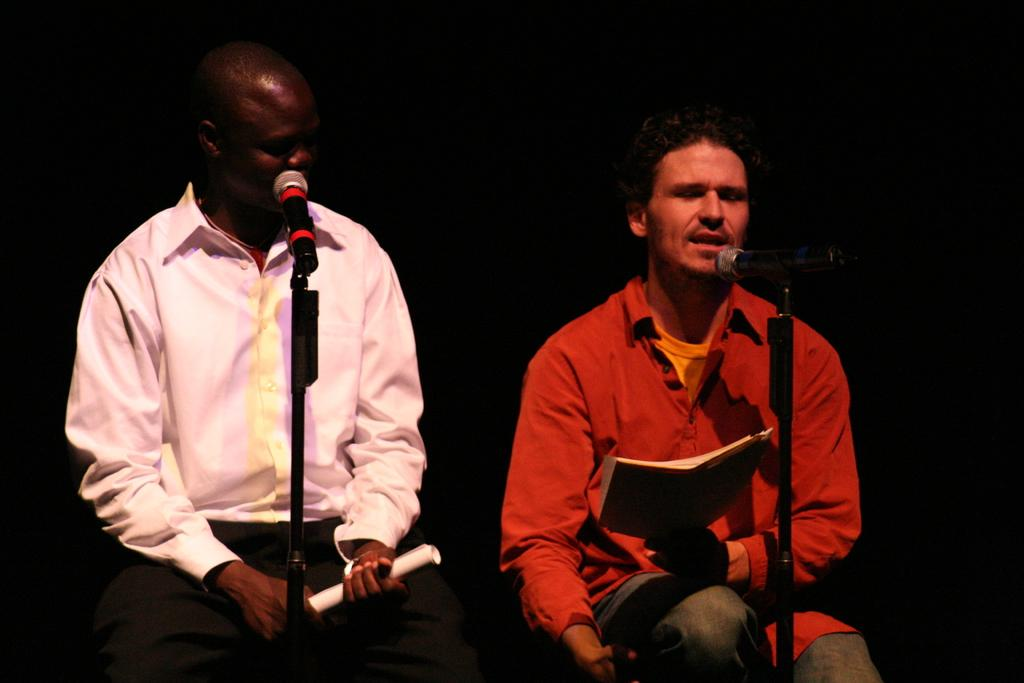How many people are in the image? There are two persons in the image. What are the two persons doing? The two persons are sitting and singing. What objects are held by each person? One person is holding a book, and the other person is holding a paper. What equipment is present for amplifying their voices? There are microphones with stands in the image. What type of knot can be seen in the image? There is no knot present in the image. Is there a fire visible in the image? No, there is no fire visible in the image. 